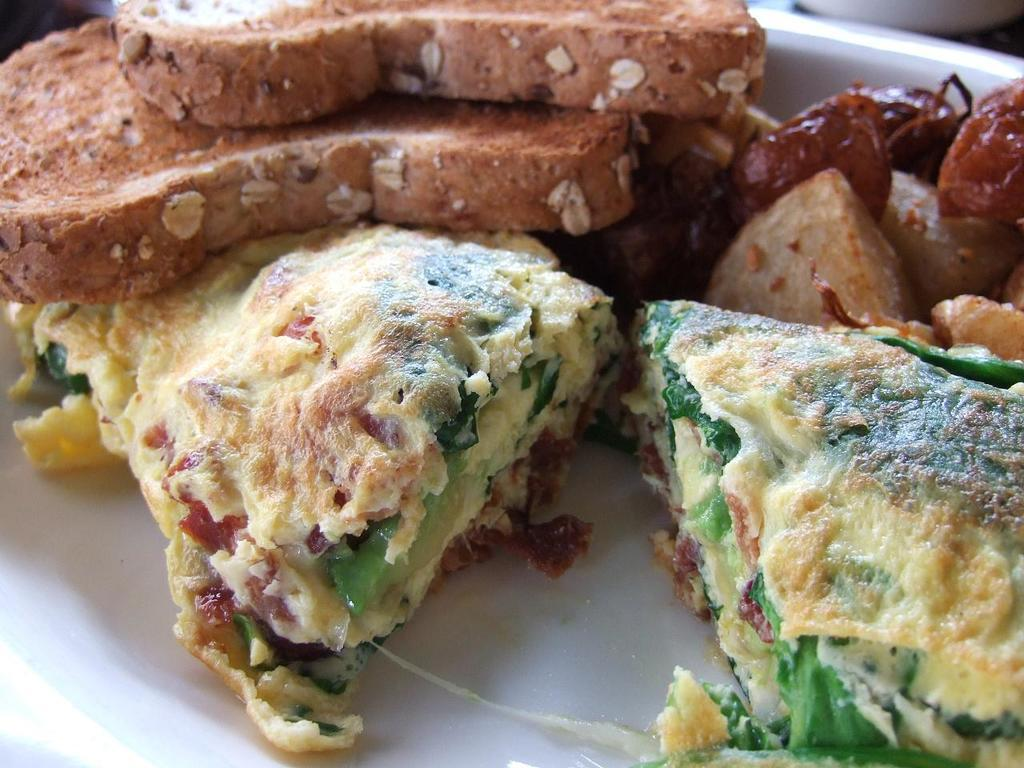What is present on the plate in the image? The plate contains a variety of dishes. Can you describe the dishes on the plate? Unfortunately, the specific dishes cannot be determined from the provided facts. What might be used to serve or eat the dishes on the plate? The plate itself can be used to serve the dishes, and utensils or other serving tools might be used to eat them. How many balloons are floating above the plate in the image? There is no mention of balloons in the provided facts, so it cannot be determined if any are present in the image. 